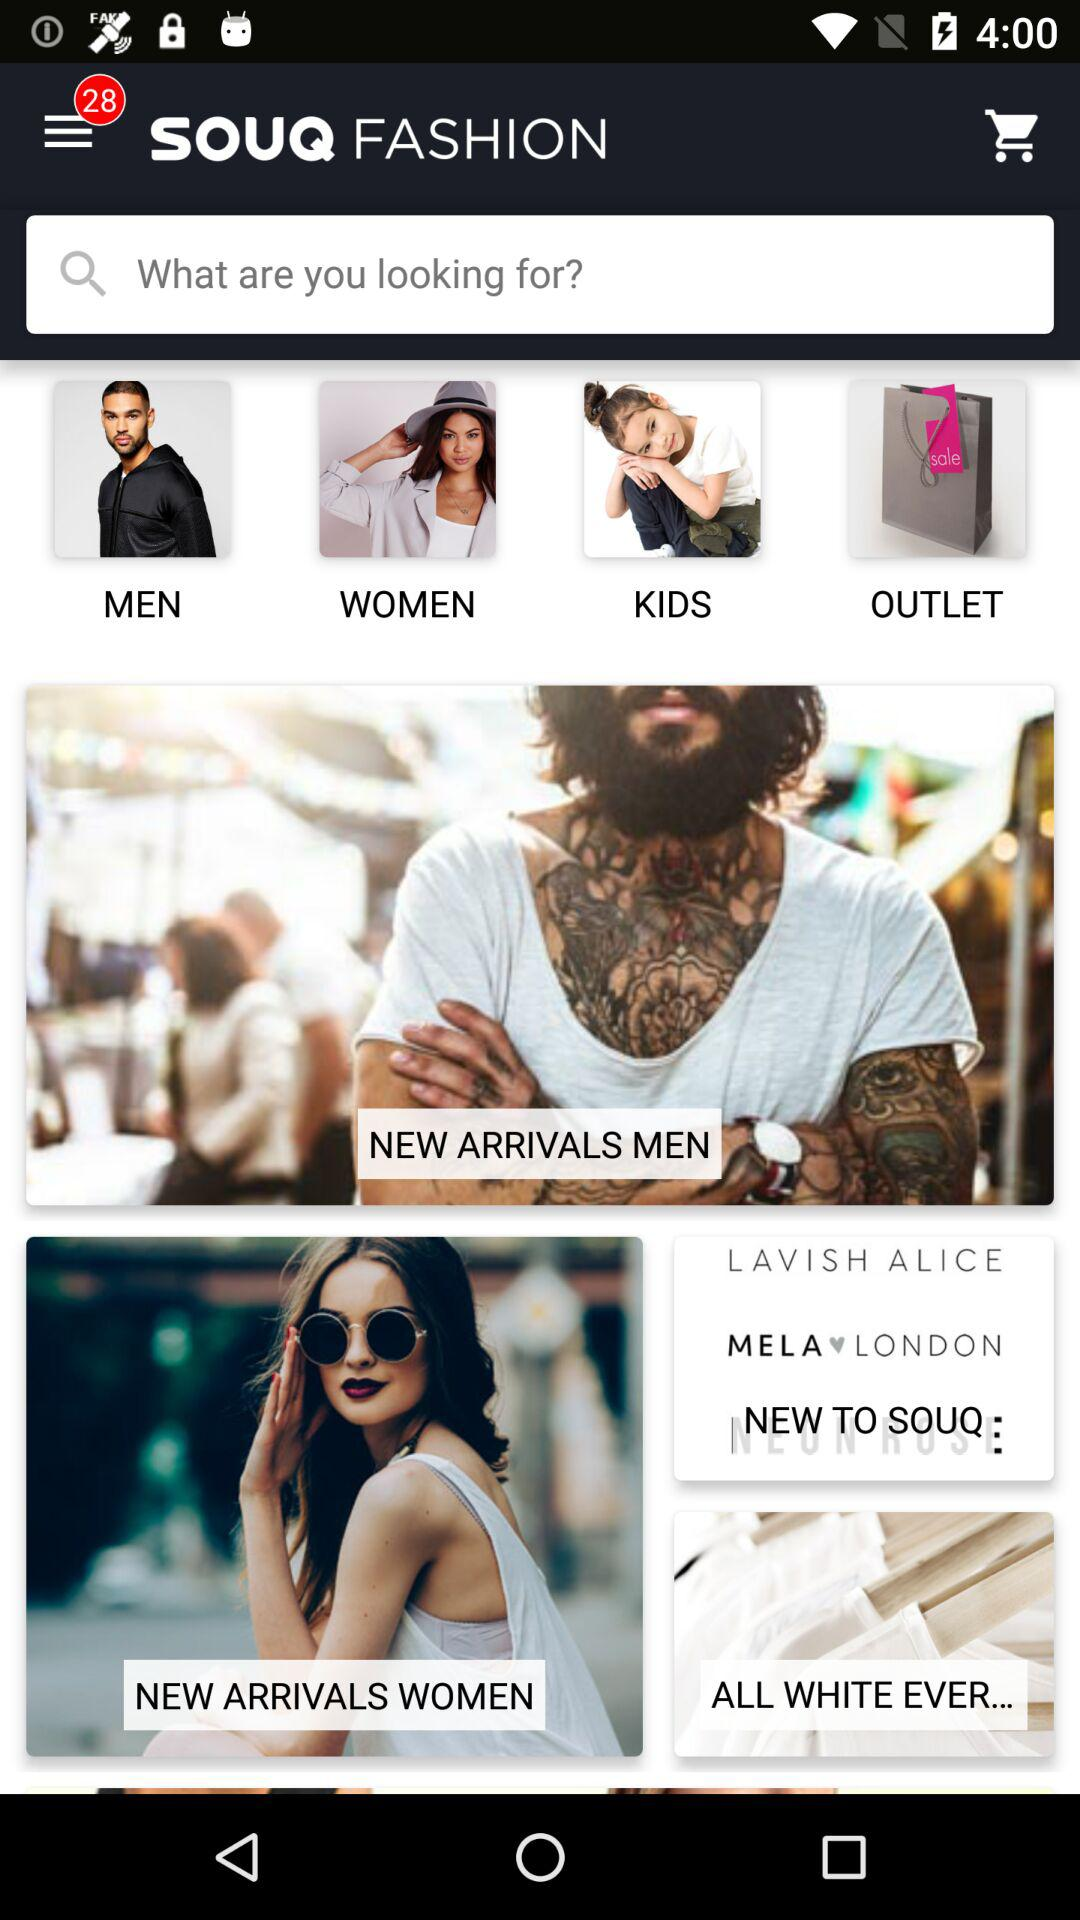What is the application name? The application name is "SOUQ FASHION". 